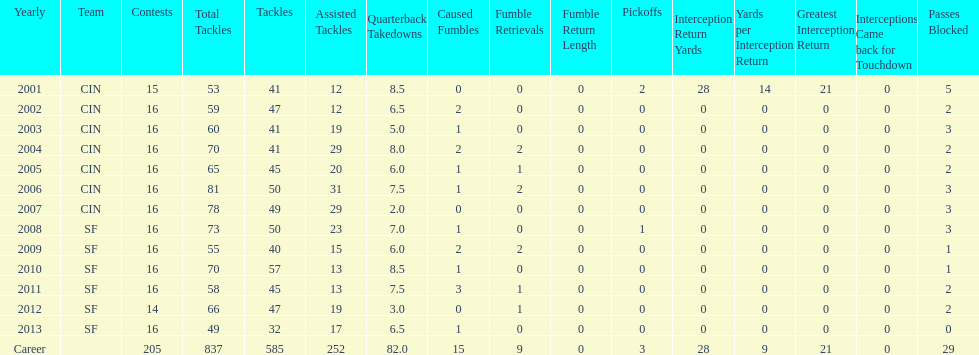How many years did he play in less than 16 games? 2. 